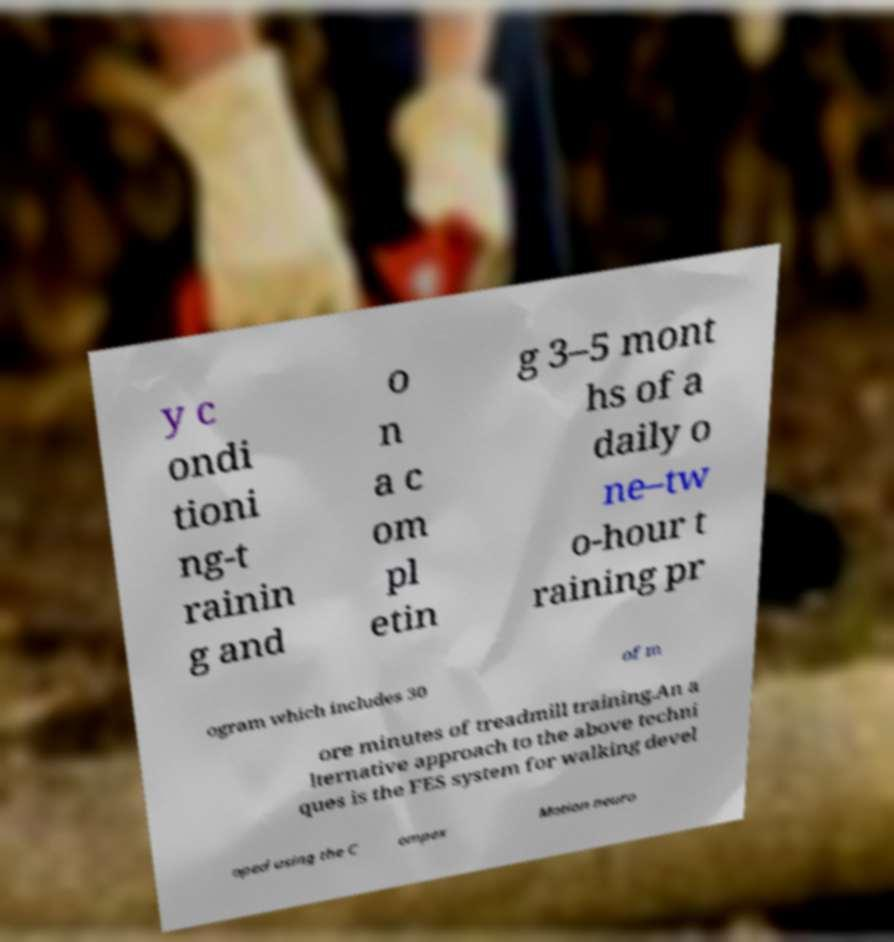I need the written content from this picture converted into text. Can you do that? y c ondi tioni ng-t rainin g and o n a c om pl etin g 3–5 mont hs of a daily o ne–tw o-hour t raining pr ogram which includes 30 of m ore minutes of treadmill training.An a lternative approach to the above techni ques is the FES system for walking devel oped using the C ompex Motion neuro 